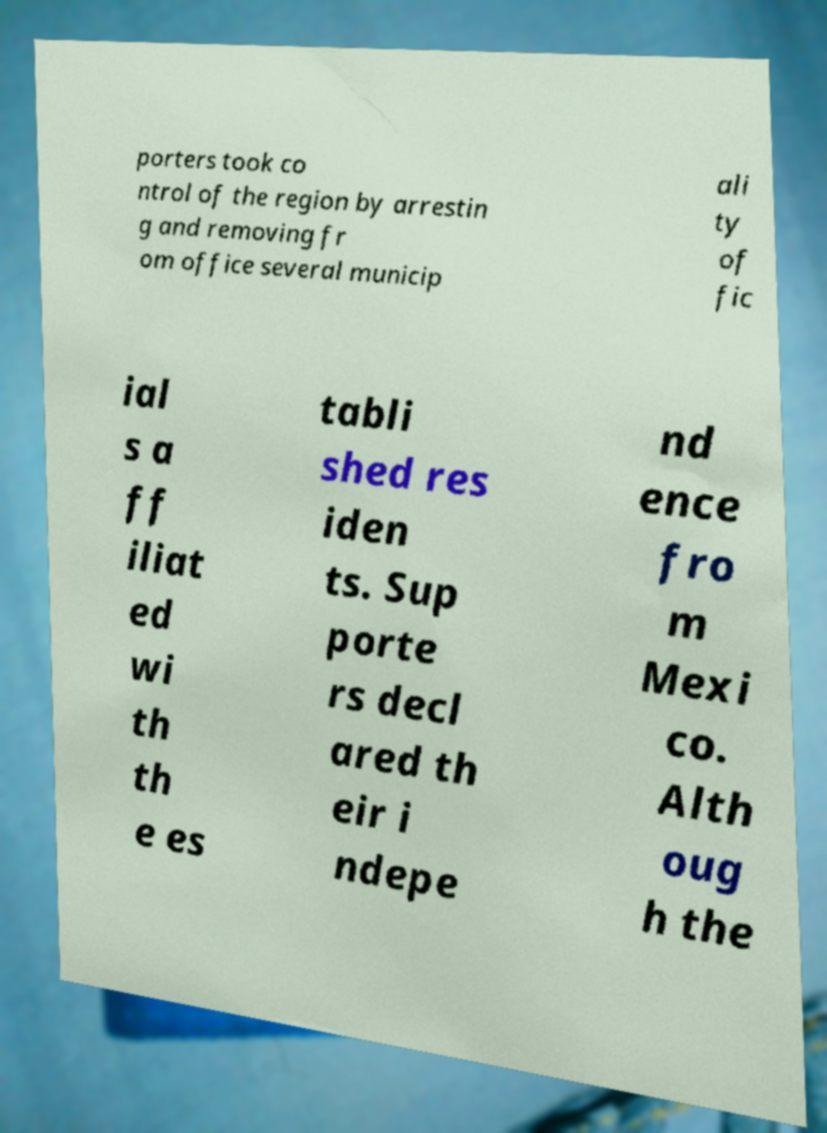I need the written content from this picture converted into text. Can you do that? porters took co ntrol of the region by arrestin g and removing fr om office several municip ali ty of fic ial s a ff iliat ed wi th th e es tabli shed res iden ts. Sup porte rs decl ared th eir i ndepe nd ence fro m Mexi co. Alth oug h the 